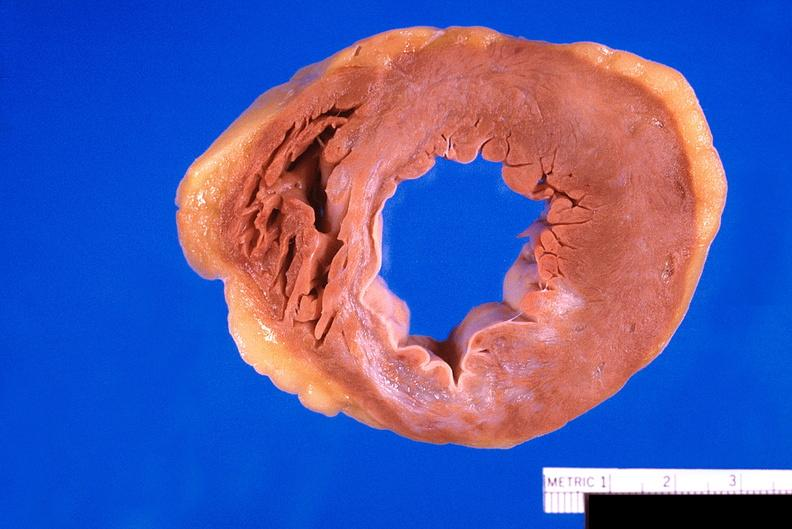where is this?
Answer the question using a single word or phrase. Heart 